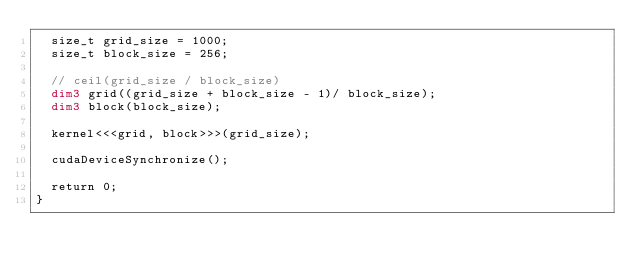Convert code to text. <code><loc_0><loc_0><loc_500><loc_500><_Cuda_>  size_t grid_size = 1000;
  size_t block_size = 256;

  // ceil(grid_size / block_size)
  dim3 grid((grid_size + block_size - 1)/ block_size);
  dim3 block(block_size);

  kernel<<<grid, block>>>(grid_size);

  cudaDeviceSynchronize();

  return 0;
}
</code> 